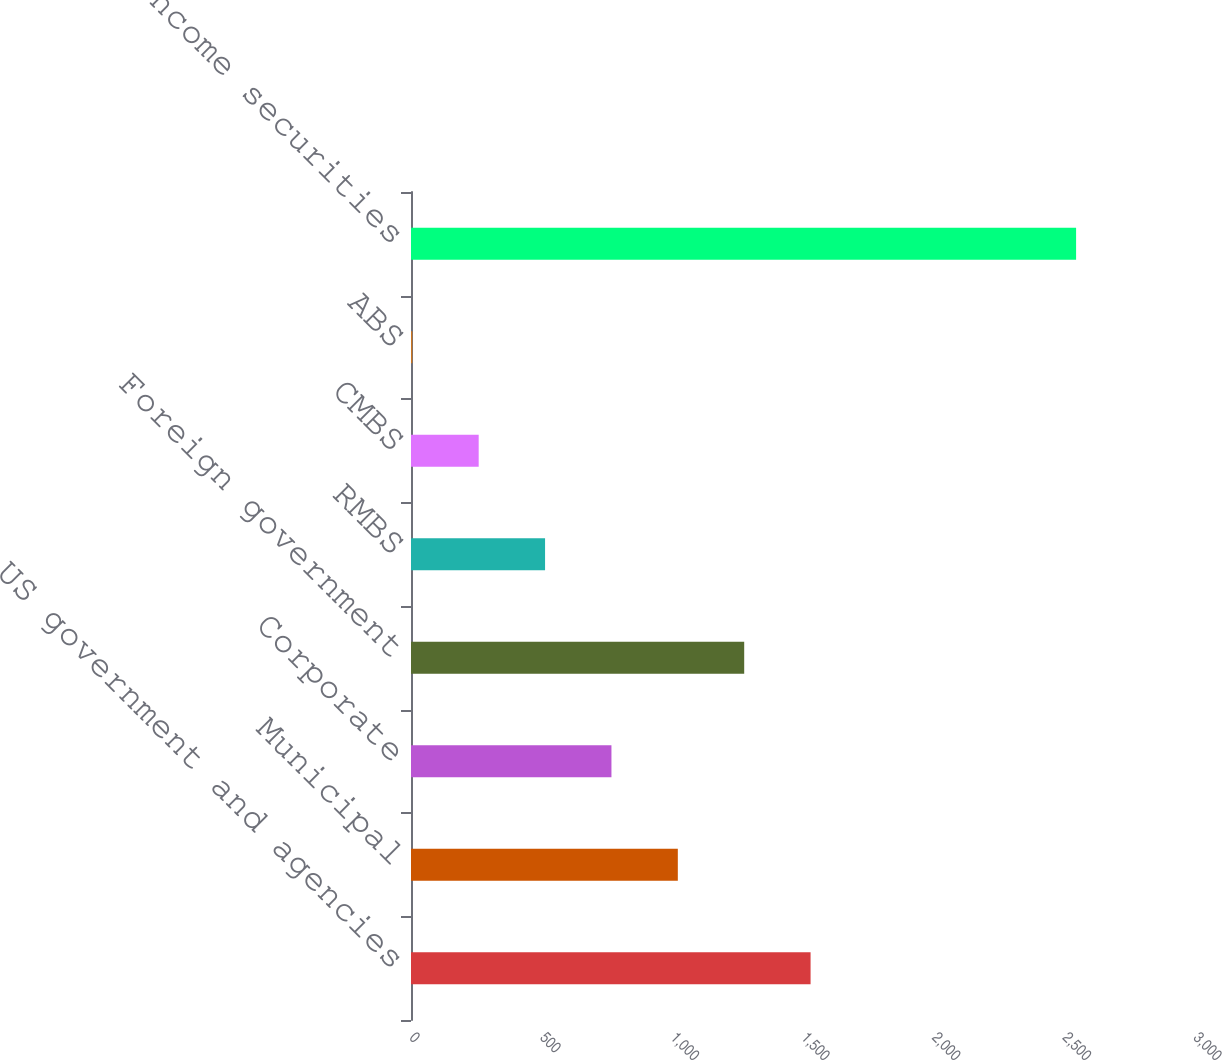<chart> <loc_0><loc_0><loc_500><loc_500><bar_chart><fcel>US government and agencies<fcel>Municipal<fcel>Corporate<fcel>Foreign government<fcel>RMBS<fcel>CMBS<fcel>ABS<fcel>Total fixed income securities<nl><fcel>1529<fcel>1021<fcel>767<fcel>1275<fcel>513<fcel>259<fcel>5<fcel>2545<nl></chart> 